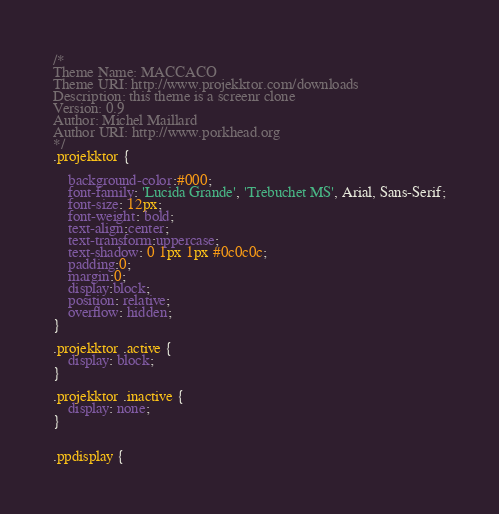Convert code to text. <code><loc_0><loc_0><loc_500><loc_500><_CSS_>/*
Theme Name: MACCACO
Theme URI: http://www.projekktor.com/downloads
Description: this theme is a screenr clone
Version: 0.9
Author: Michel Maillard
Author URI: http://www.porkhead.org
*/
.projekktor {
    
    background-color:#000;
    font-family: 'Lucida Grande', 'Trebuchet MS', Arial, Sans-Serif;
    font-size: 12px;
    font-weight: bold;
    text-align:center;
    text-transform:uppercase;
    text-shadow: 0 1px 1px #0c0c0c;
    padding:0;
    margin:0;
    display:block;
    position: relative;
    overflow: hidden;    
}

.projekktor .active {
    display: block;
}

.projekktor .inactive {
    display: none;
}


.ppdisplay {</code> 